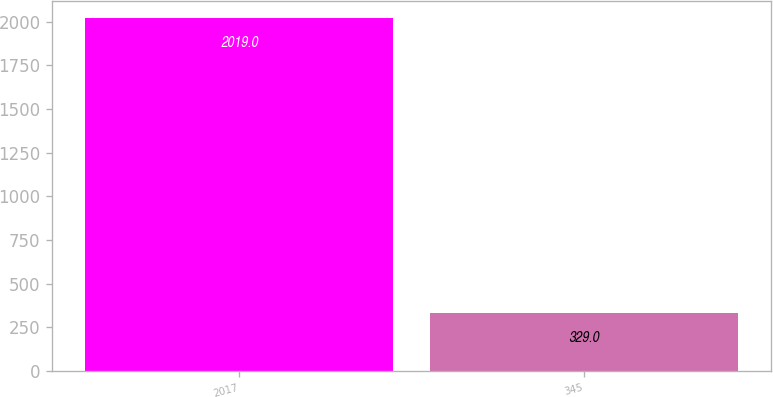Convert chart. <chart><loc_0><loc_0><loc_500><loc_500><bar_chart><fcel>2017<fcel>345<nl><fcel>2019<fcel>329<nl></chart> 